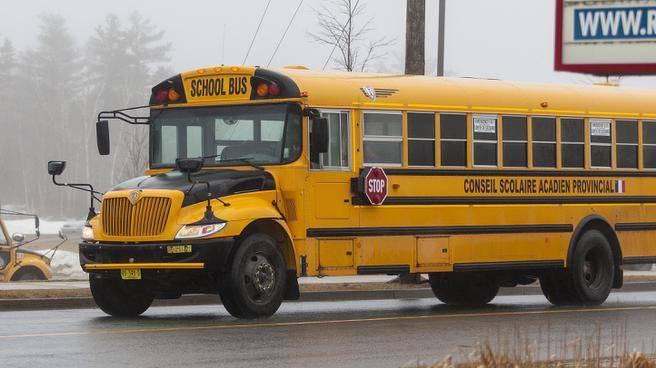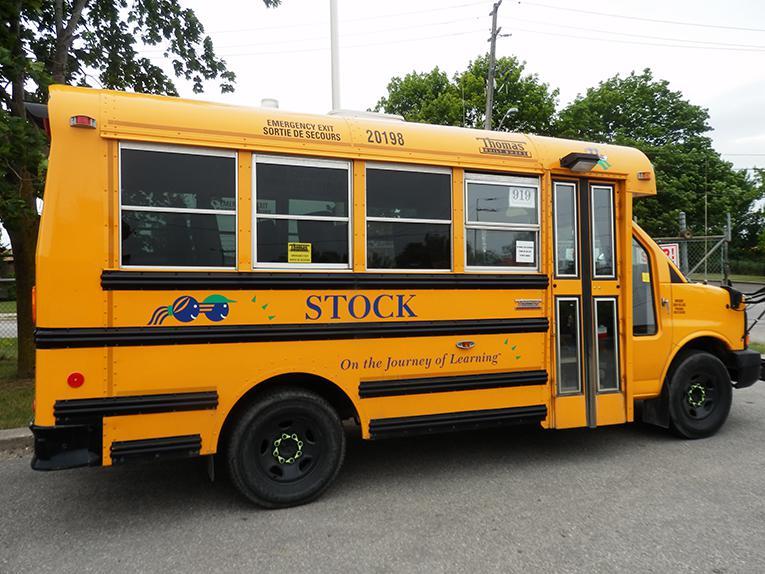The first image is the image on the left, the second image is the image on the right. Given the left and right images, does the statement "A bus is in the sun." hold true? Answer yes or no. No. The first image is the image on the left, the second image is the image on the right. Analyze the images presented: Is the assertion "The buses in the left and right images are displayed horizontally and back-to-back." valid? Answer yes or no. Yes. 